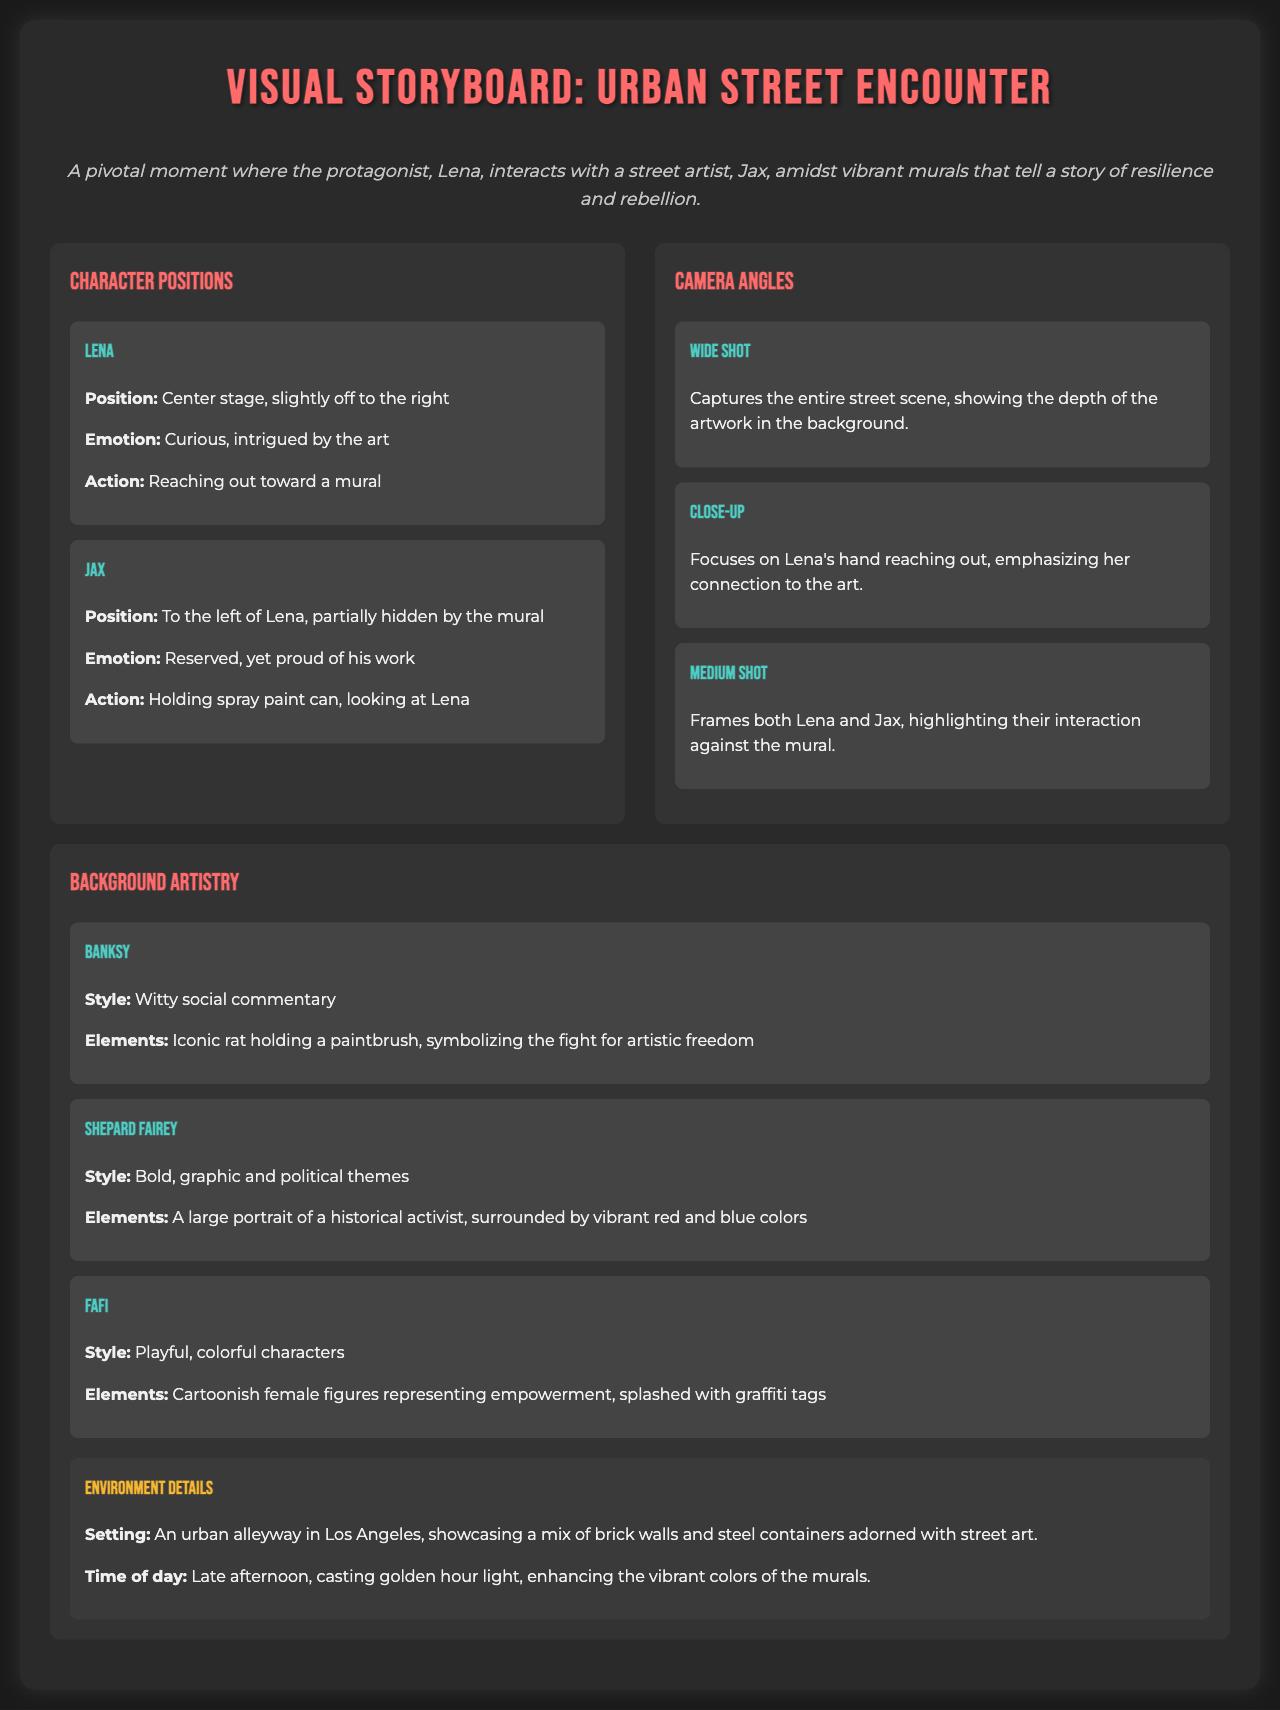What is the title of the storyboard? The title appears at the top of the document, indicating the focus of the visual storyboard.
Answer: Visual Storyboard: Urban Street Encounter Who are the main characters in the scene? The characters are mentioned in their respective sections detailing their positions and actions.
Answer: Lena and Jax What is Lena's position in the scene? The document specifies where Lena is located in relation to the scene and other characters.
Answer: Center stage, slightly off to the right What emotion is Jax expressing? The emotion is described alongside Jax's position and actions, reflecting his character's feelings.
Answer: Reserved, yet proud of his work What style is associated with Banksy's artwork? The style is described in the background artistry section as it relates to Banksy's contributions.
Answer: Witty social commentary What time of day is depicted in the scene? The scene's timing is mentioned, indicating the period and lighting in the setting.
Answer: Late afternoon Which angle captures Lena's hand reaching out? The angles specified guide how different parts of the scene are shown, including significant actions.
Answer: Close-up What kind of setting is described for the scene? The setting is outlined in the environment details, providing context for the action.
Answer: An urban alleyway in Los Angeles How many murals are featured in the background artistry section? The number of murals is directly mentioned in the document, relating to the background artistry focus.
Answer: Three murals What action is Lena performing in the scene? The action is detailed as part of Lena's characterization, showing her interaction with the art.
Answer: Reaching out toward a mural 